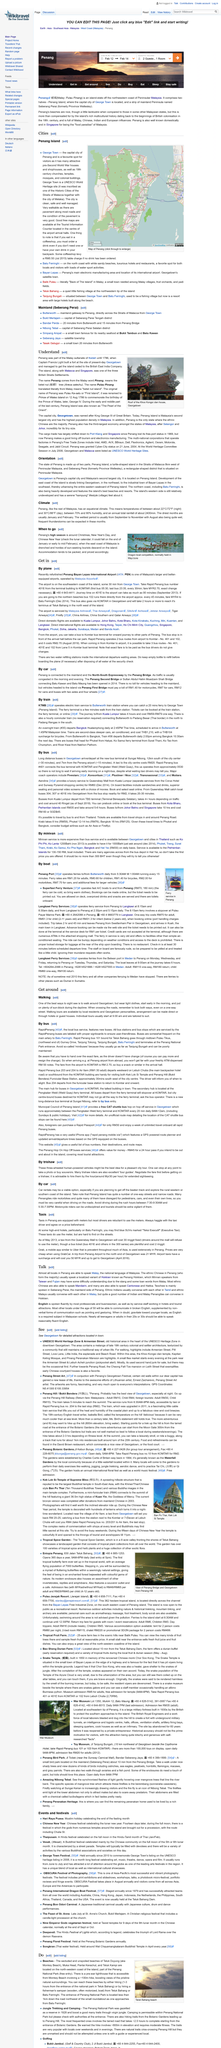Highlight a few significant elements in this photo. In Penang, taxis are equipped with meters, but many drivers are hesitant to use them. What is Teluk Duyung also known as? Aside from its official name, Teluk Duyung, it is also commonly referred to as Monkey Beach. Seberang Perai, the mainland side of Penang, is where Teochew is mainly spoken. The UNESCO Heritage Zone is located in the heart of downtown Georgetown. In Penang, the primary language spoken by the locals is Malay, which is also the national language of Malaysia. 